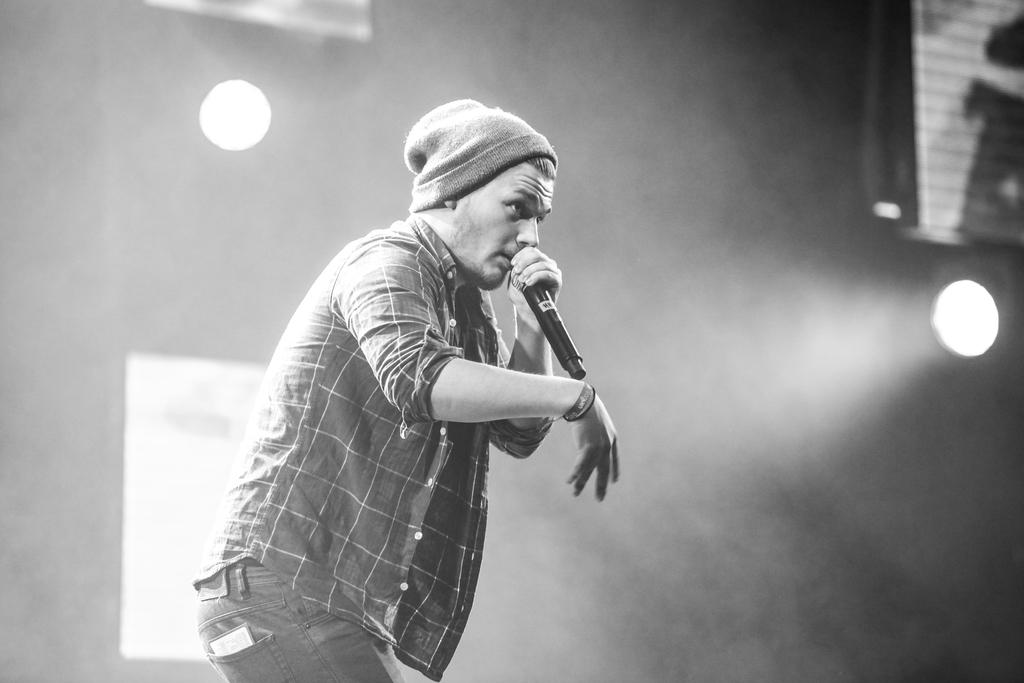Who is the main subject in the image? There is a man in the center of the image. What is the man doing in the image? The man is standing and appears to be singing. What object is the man holding in the image? The man is holding a microphone. What can be seen in the background of the image? There is a wall and lights in the background of the image. How many pies are being exchanged between the man and the audience in the image? There are no pies present in the image, nor is there any indication of an exchange between the man and the audience. 